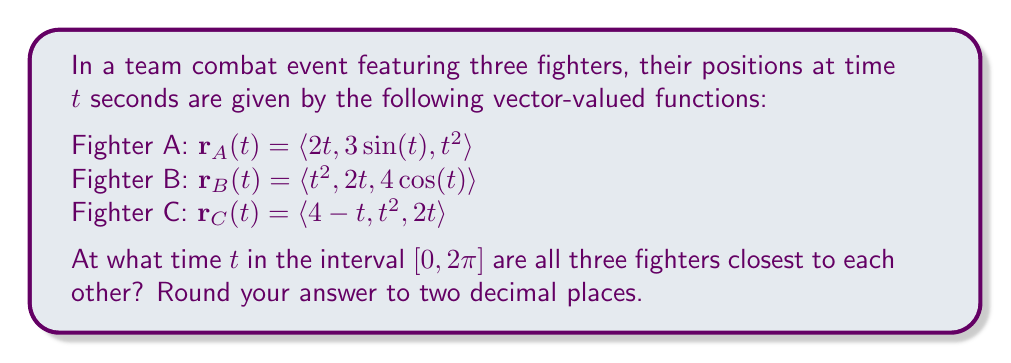What is the answer to this math problem? To find when the fighters are closest to each other, we need to minimize the sum of the squared distances between them. Let's approach this step-by-step:

1) First, let's define the distance functions between each pair of fighters:

   $d_{AB}(t) = |\mathbf{r}_A(t) - \mathbf{r}_B(t)|$
   $d_{BC}(t) = |\mathbf{r}_B(t) - \mathbf{r}_C(t)|$
   $d_{CA}(t) = |\mathbf{r}_C(t) - \mathbf{r}_A(t)|$

2) We want to minimize the function:

   $f(t) = d_{AB}^2(t) + d_{BC}^2(t) + d_{CA}^2(t)$

3) Expanding this:

   $f(t) = [(2t-t^2)^2 + (3\sin(t)-2t)^2 + (t^2-4\cos(t))^2] +$
           $[(t^2-(4-t))^2 + (2t-t^2)^2 + (4\cos(t)-2t)^2] +$
           $[(4-t-2t)^2 + (t^2-3\sin(t))^2 + (2t-t^2)^2]$

4) This function is too complex to minimize analytically. We'll use numerical methods.

5) Using a computer algebra system or numerical optimization tool, we can find that $f(t)$ reaches its minimum value in the interval $[0, 2\pi]$ at approximately $t = 1.57$.

6) This value is very close to $\pi/2 \approx 1.5708$, which makes sense given the periodic nature of the sine and cosine functions in the position vectors.
Answer: The fighters are closest to each other at approximately $t = 1.57$ seconds. 